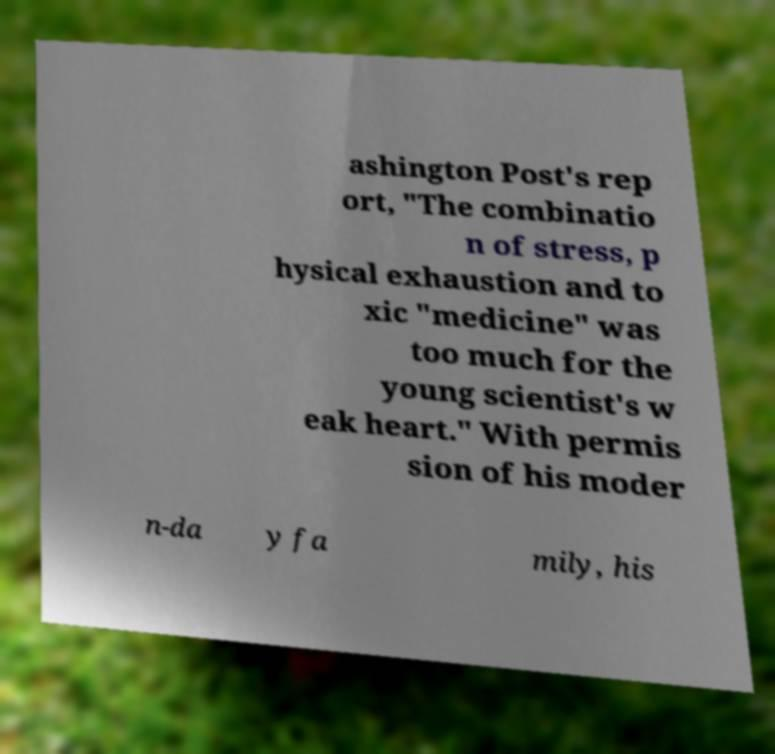Could you assist in decoding the text presented in this image and type it out clearly? ashington Post's rep ort, "The combinatio n of stress, p hysical exhaustion and to xic "medicine" was too much for the young scientist's w eak heart." With permis sion of his moder n-da y fa mily, his 